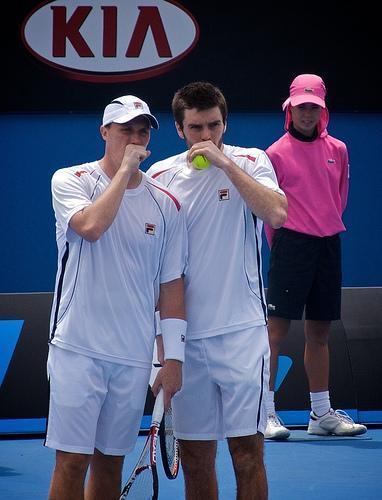How many people are wearing white?
Give a very brief answer. 2. How many people are there?
Give a very brief answer. 3. 